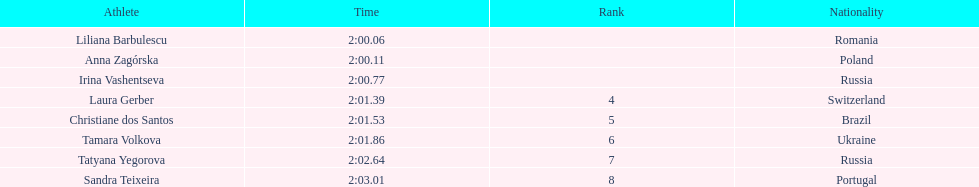Anna zagorska recieved 2nd place, what was her time? 2:00.11. 